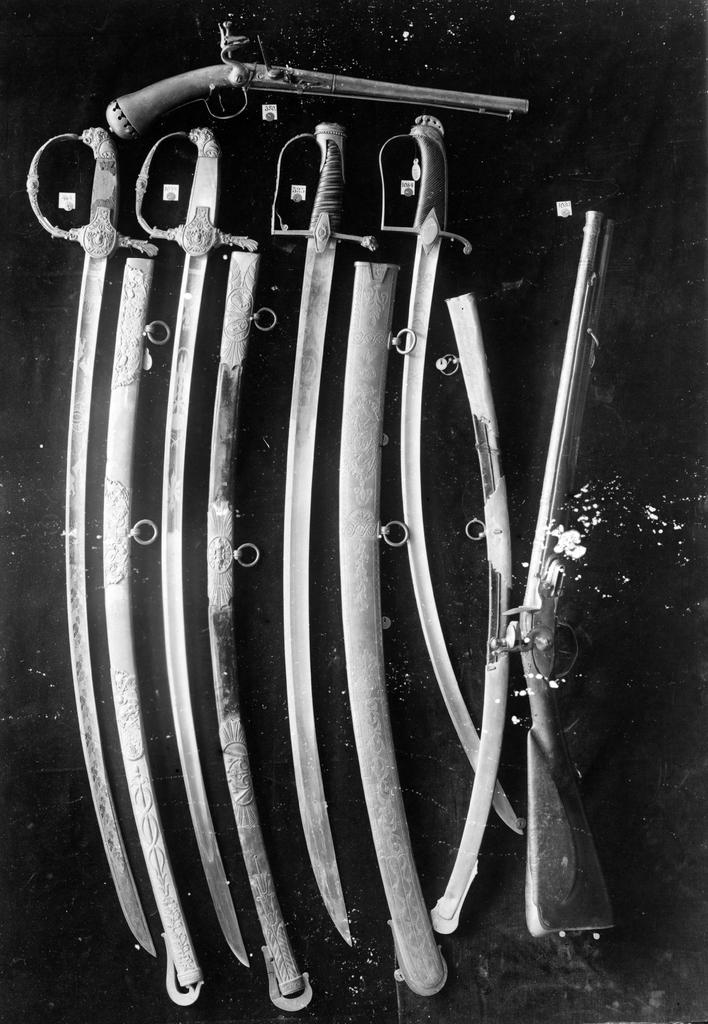What type of weapons are present in the image? There are swords and guns in the image. Where are the swords and guns placed in the image? The swords and guns are placed on a black color wall. Can you tell me how many worms are crawling on the wall in the image? There are no worms present in the image; it features swords and guns placed on a black color wall. What level of expertise is required to handle the weapons in the image? The provided facts do not indicate the level of expertise required to handle the weapons in the image. 